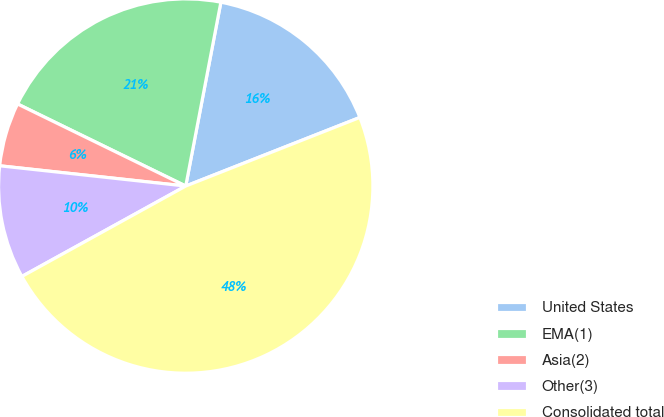Convert chart. <chart><loc_0><loc_0><loc_500><loc_500><pie_chart><fcel>United States<fcel>EMA(1)<fcel>Asia(2)<fcel>Other(3)<fcel>Consolidated total<nl><fcel>16.02%<fcel>20.78%<fcel>5.5%<fcel>9.75%<fcel>47.95%<nl></chart> 